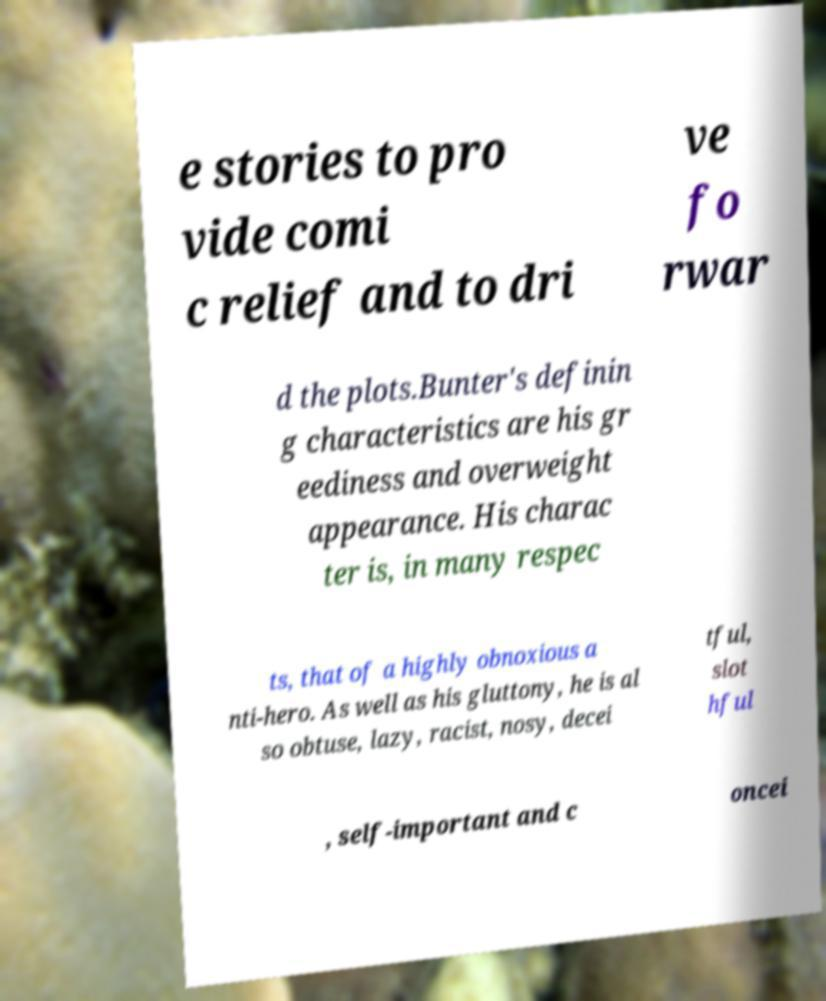I need the written content from this picture converted into text. Can you do that? e stories to pro vide comi c relief and to dri ve fo rwar d the plots.Bunter's definin g characteristics are his gr eediness and overweight appearance. His charac ter is, in many respec ts, that of a highly obnoxious a nti-hero. As well as his gluttony, he is al so obtuse, lazy, racist, nosy, decei tful, slot hful , self-important and c oncei 